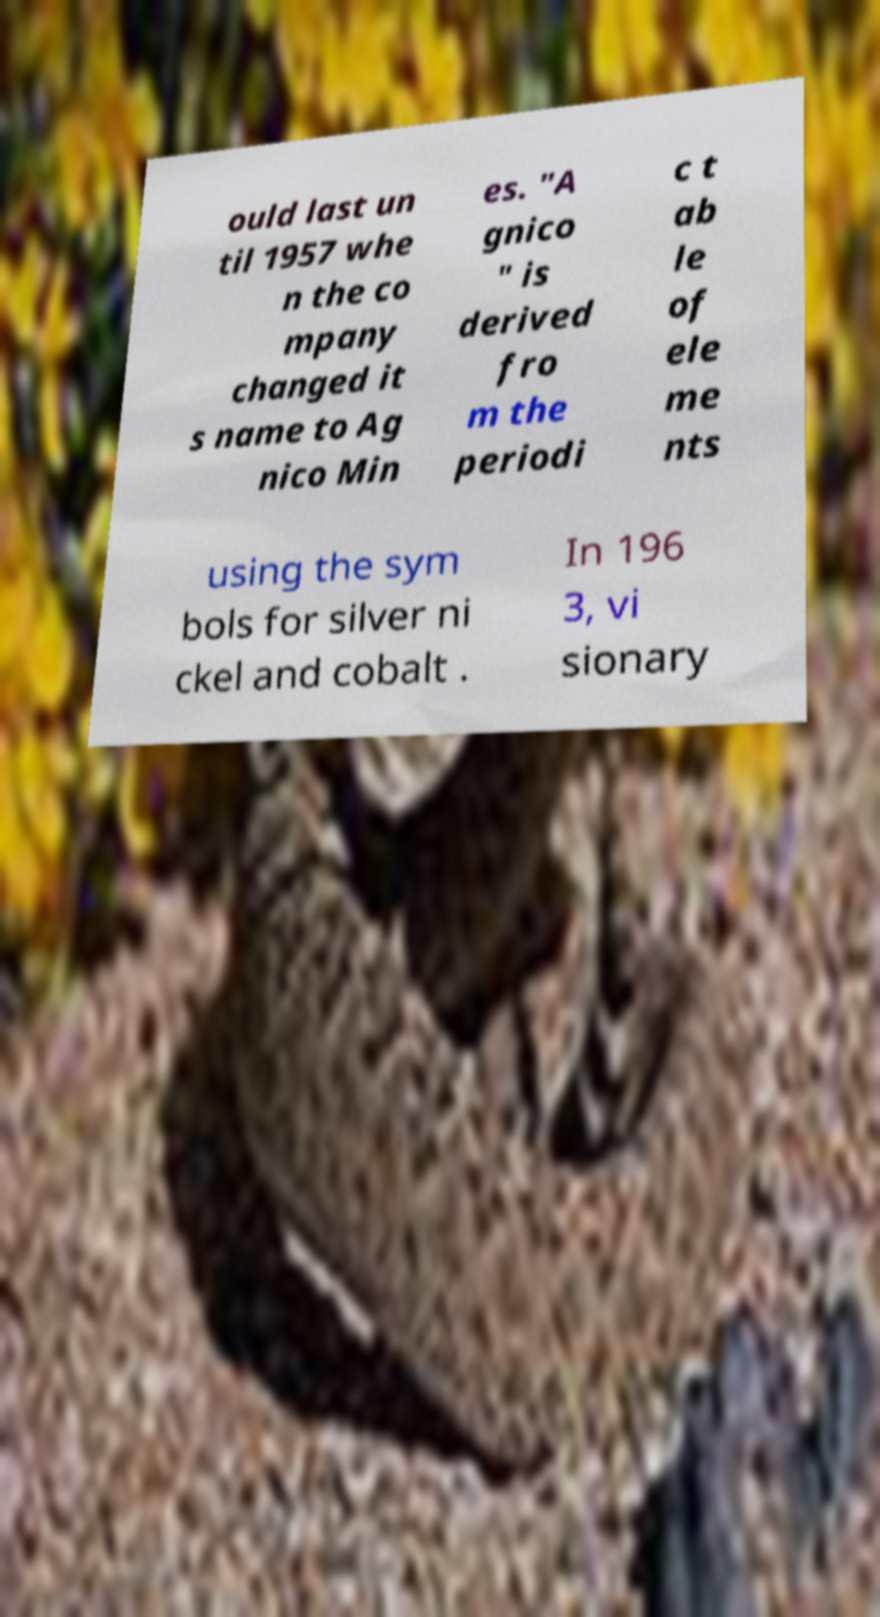For documentation purposes, I need the text within this image transcribed. Could you provide that? ould last un til 1957 whe n the co mpany changed it s name to Ag nico Min es. "A gnico " is derived fro m the periodi c t ab le of ele me nts using the sym bols for silver ni ckel and cobalt . In 196 3, vi sionary 